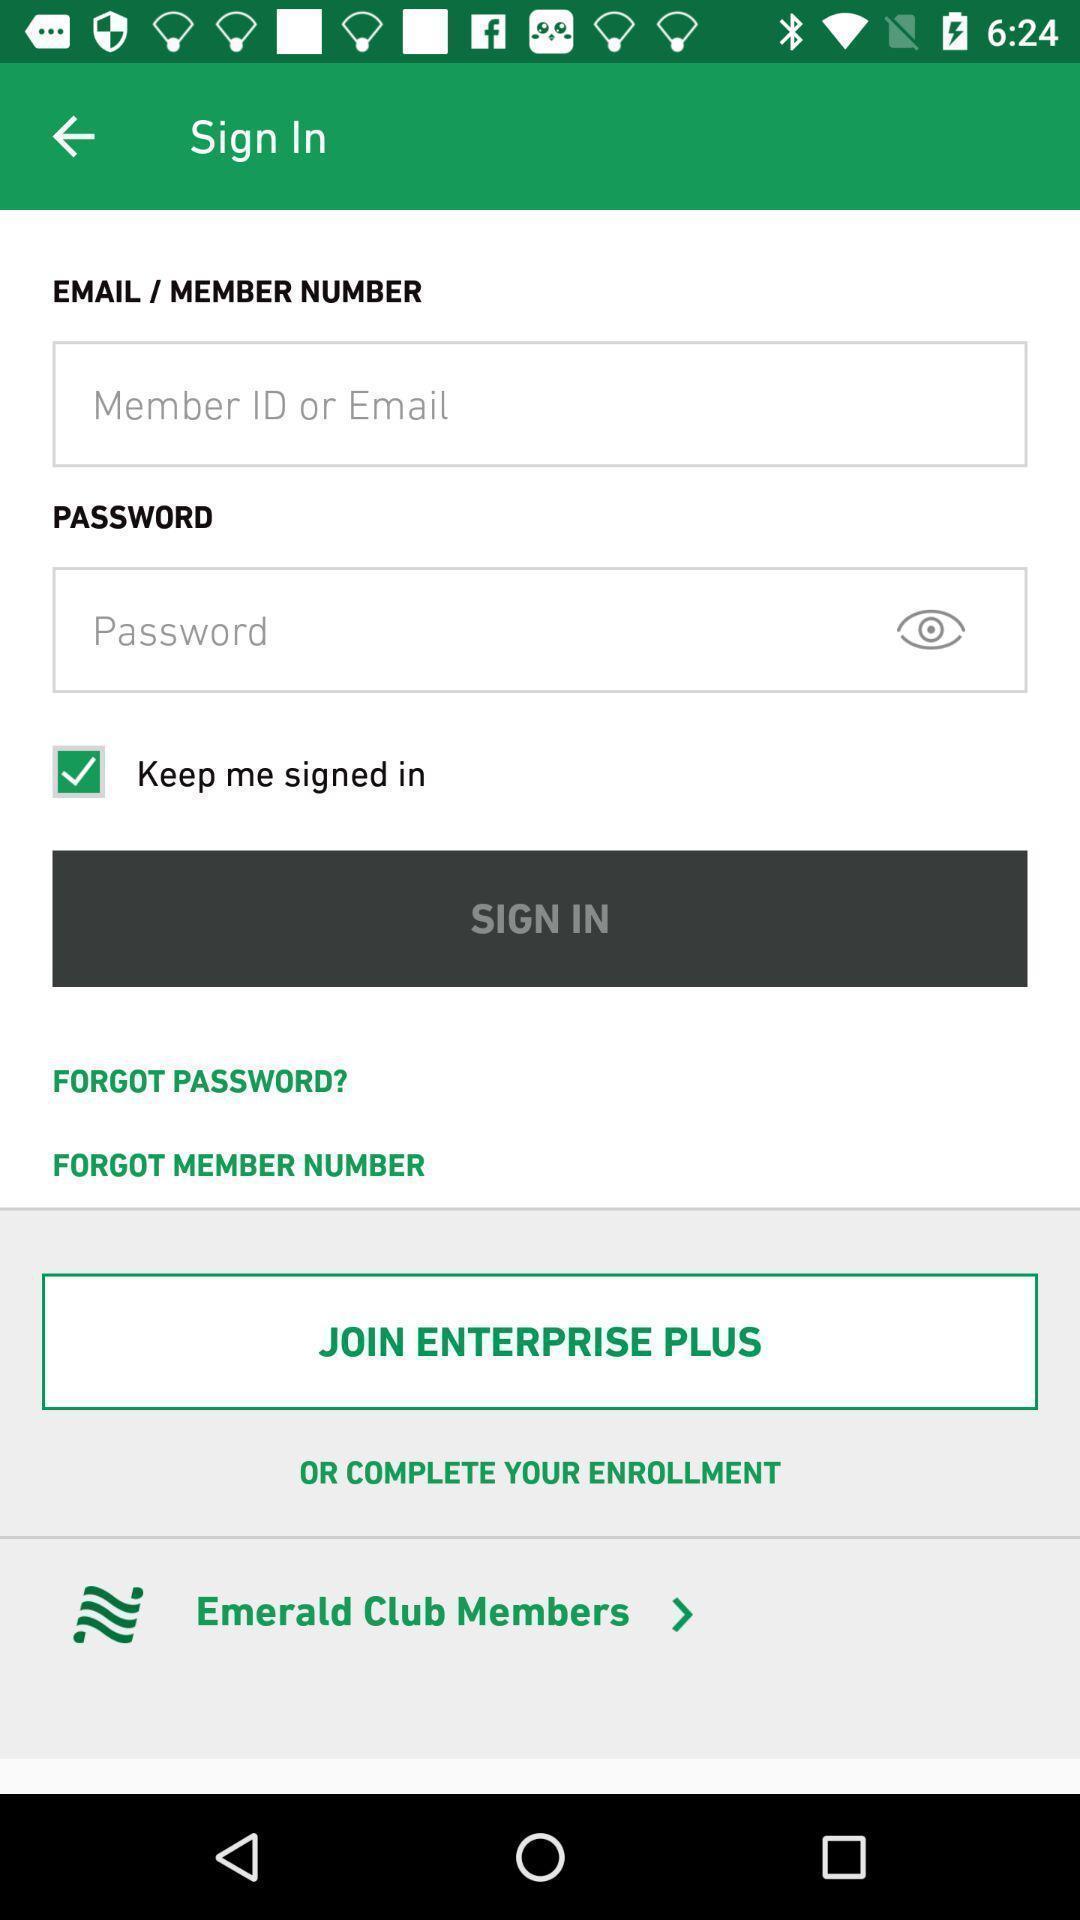What can you discern from this picture? Sign in page s. 